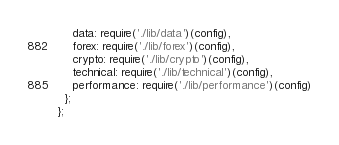Convert code to text. <code><loc_0><loc_0><loc_500><loc_500><_JavaScript_>    data: require('./lib/data')(config),
    forex: require('./lib/forex')(config),
    crypto: require('./lib/crypto')(config),
    technical: require('./lib/technical')(config),
    performance: require('./lib/performance')(config)
  };
};
</code> 